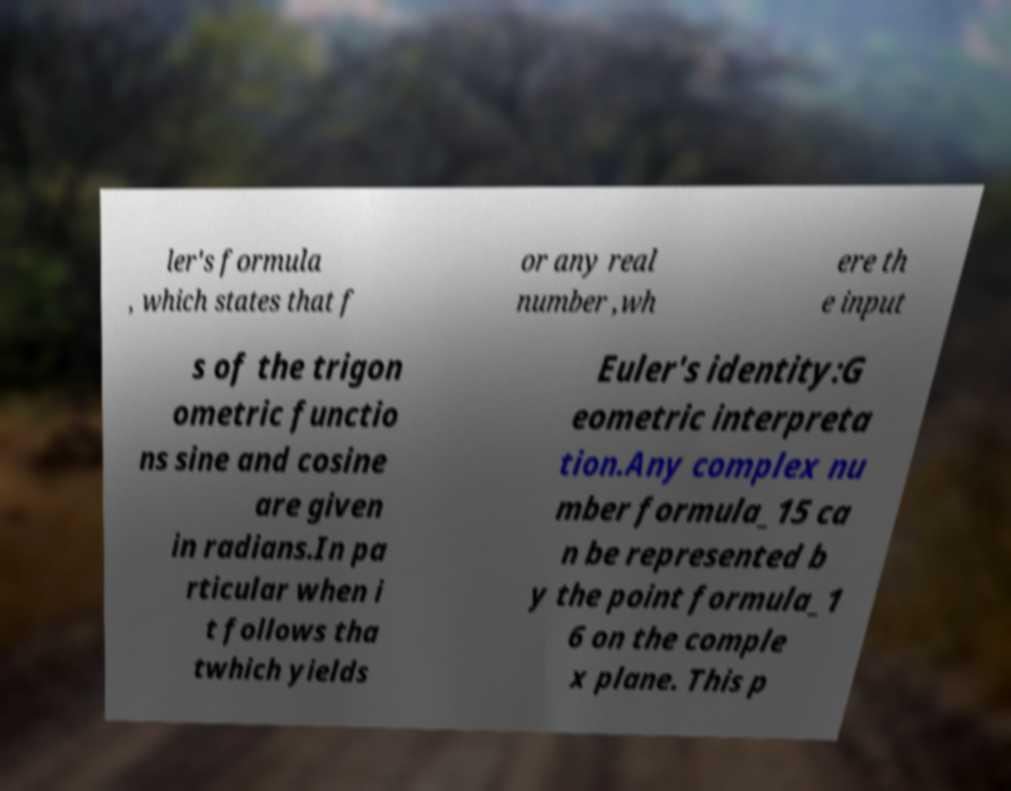Could you assist in decoding the text presented in this image and type it out clearly? ler's formula , which states that f or any real number ,wh ere th e input s of the trigon ometric functio ns sine and cosine are given in radians.In pa rticular when i t follows tha twhich yields Euler's identity:G eometric interpreta tion.Any complex nu mber formula_15 ca n be represented b y the point formula_1 6 on the comple x plane. This p 